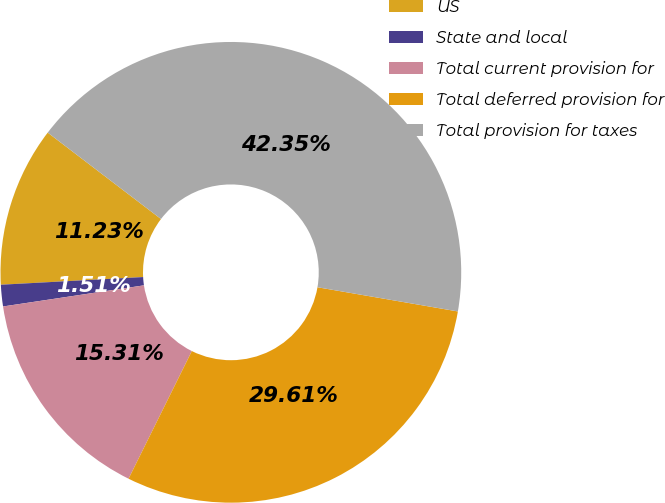Convert chart to OTSL. <chart><loc_0><loc_0><loc_500><loc_500><pie_chart><fcel>US<fcel>State and local<fcel>Total current provision for<fcel>Total deferred provision for<fcel>Total provision for taxes<nl><fcel>11.23%<fcel>1.51%<fcel>15.31%<fcel>29.61%<fcel>42.35%<nl></chart> 